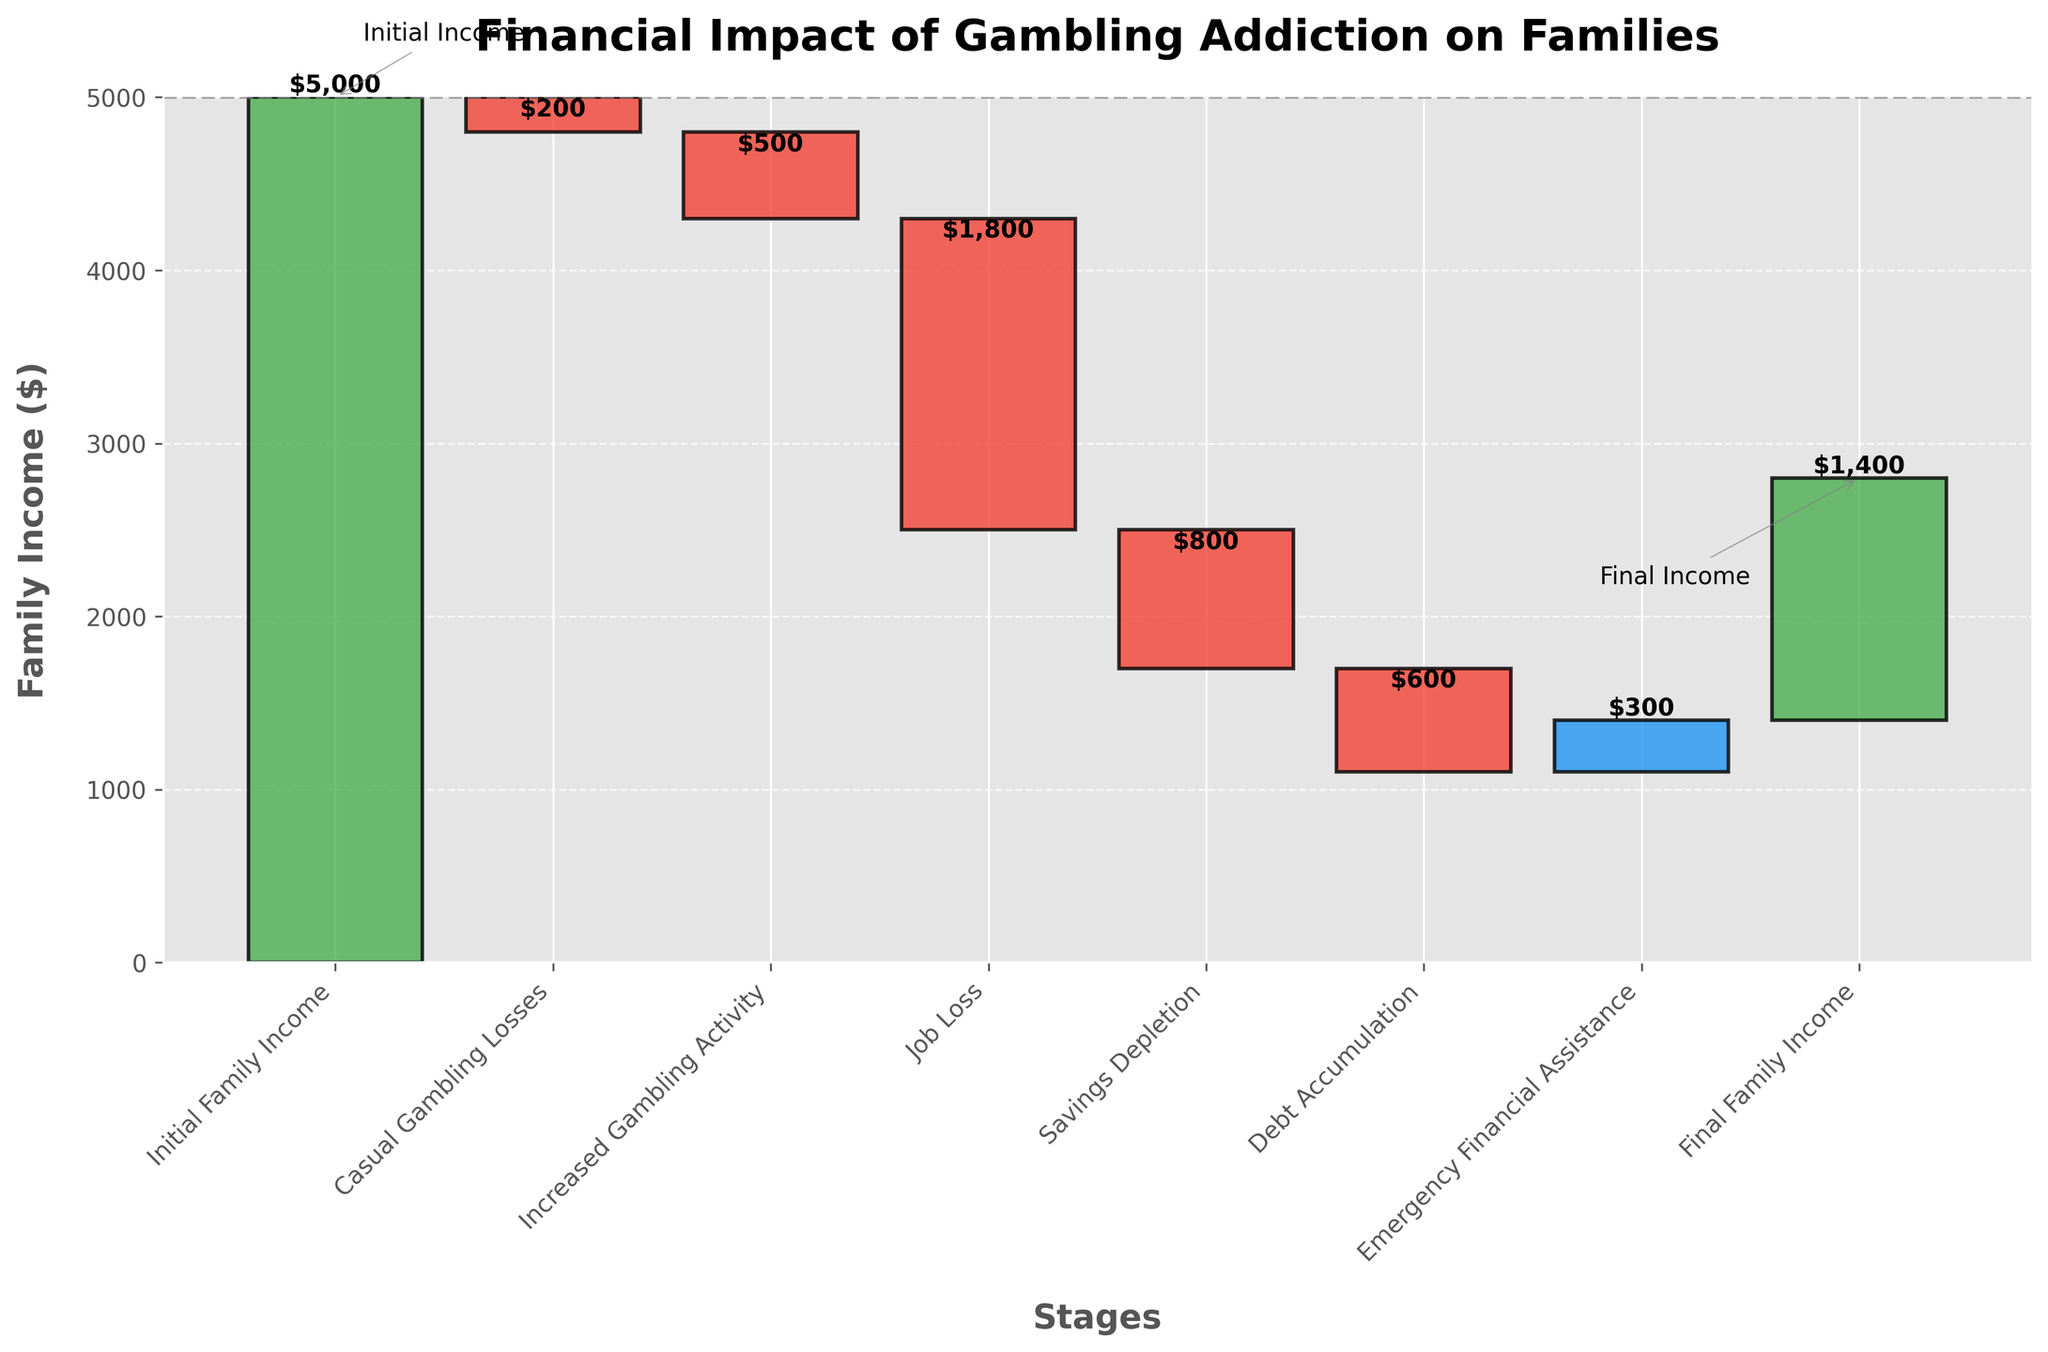What is the initial family income shown in the chart? The chart has an initial bar labeled "Initial Family Income" with a value of 5000.
Answer: 5000 How much income is lost due to casual gambling? The bar labeled "Casual Gambling Losses" shows a negative value of 200.
Answer: 200 What is the final family income? The chart has a final bar labeled "Final Family Income" with a value of 1400.
Answer: 1400 What is the income drop after job loss? The bar labeled "Job Loss" has a negative value of 1800, indicating a drop of 1800 in family income.
Answer: 1800 Which stage has the highest negative impact on family income? By comparing the negative values, "Job Loss" has the highest negative value of 1800, which is the largest income deduction in the chart.
Answer: Job Loss What is the cumulative loss from casual gambling and increased gambling activity? Adding the losses from "Casual Gambling Losses" (-200) and "Increased Gambling Activity" (-500): -200 + (-500) = -700.
Answer: 700 How does savings depletion impact the family's income compared to debt accumulation? "Savings Depletion" shows a negative impact of 800, while "Debt Accumulation" shows a negative impact of 600. Comparing these two, savings depletion impacts more.
Answer: Savings Depletion impacts more What is the overall increase in income from emergency financial assistance? The bar labeled "Emergency Financial Assistance" shows a positive value of 300.
Answer: 300 What is the difference between the initial and final family income? The initial income is 5000, and the final income is 1400. The difference is 5000 - 1400 = 3600.
Answer: 3600 Is there any stage that improved the family's financial situation? The only positive impact shown is "Emergency Financial Assistance" with a value of 300.
Answer: Emergency Financial Assistance 